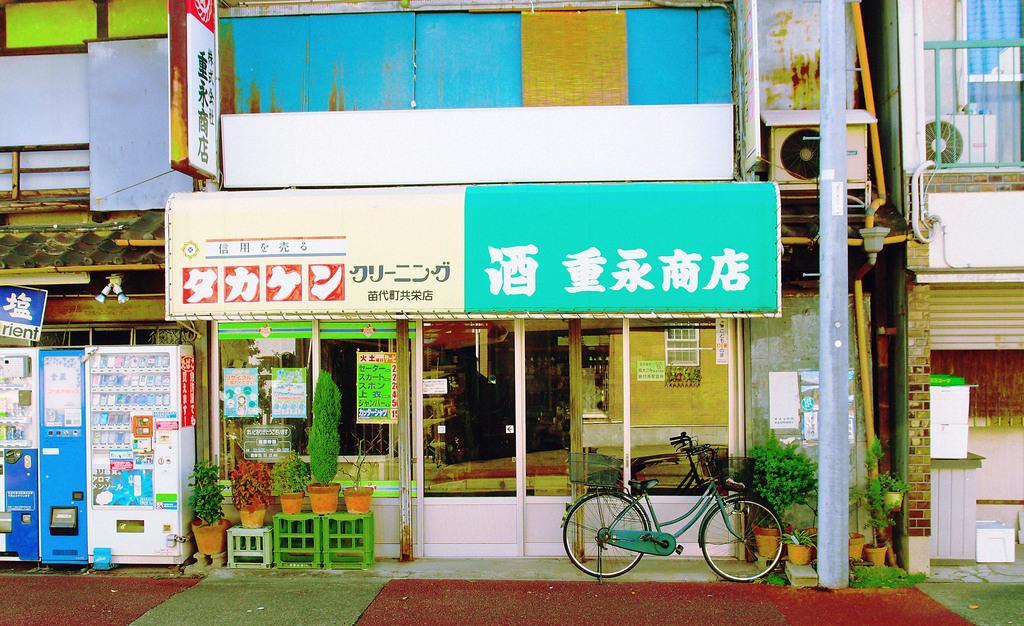How would you summarize this image in a sentence or two? It looks like a store, there is a cycle parked in front of this. In the left side there are few machines. 